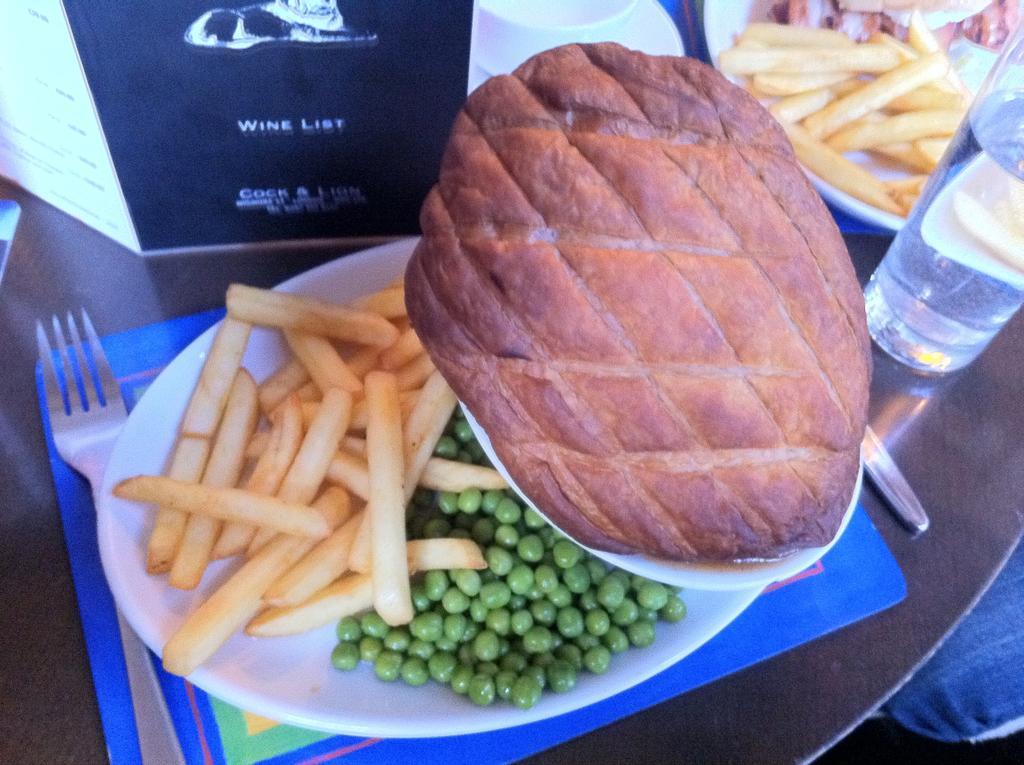Describe this image in one or two sentences. In this picture we can see a fork, bottle, cup, saucer, menu card, plate with fries and food items on it and these all are placed on a table. 